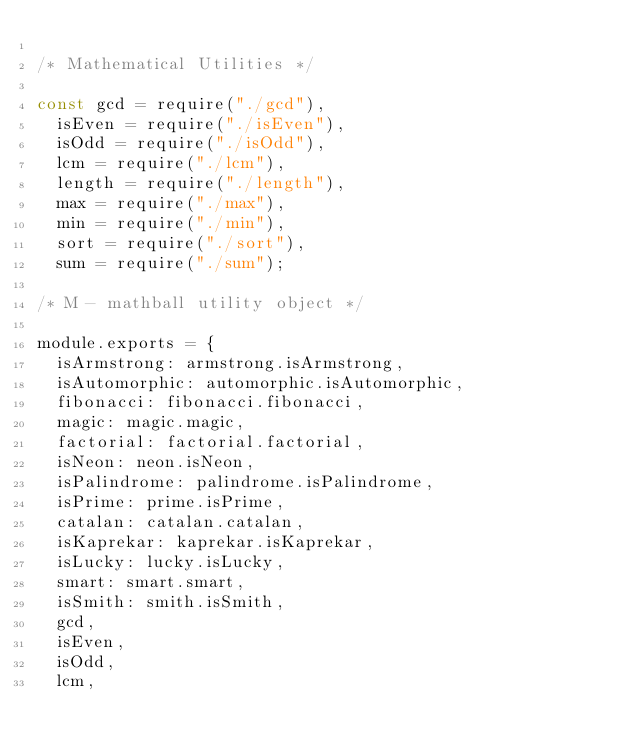Convert code to text. <code><loc_0><loc_0><loc_500><loc_500><_JavaScript_>
/* Mathematical Utilities */

const gcd = require("./gcd"),
	isEven = require("./isEven"),
	isOdd = require("./isOdd"),
	lcm = require("./lcm"),
	length = require("./length"),
	max = require("./max"),
	min = require("./min"),
	sort = require("./sort"),
	sum = require("./sum");

/* M - mathball utility object */

module.exports = {
	isArmstrong: armstrong.isArmstrong,
	isAutomorphic: automorphic.isAutomorphic,
	fibonacci: fibonacci.fibonacci,
	magic: magic.magic,
	factorial: factorial.factorial,
	isNeon: neon.isNeon,
	isPalindrome: palindrome.isPalindrome,
	isPrime: prime.isPrime,
	catalan: catalan.catalan,
	isKaprekar: kaprekar.isKaprekar,
	isLucky: lucky.isLucky,
	smart: smart.smart,
	isSmith: smith.isSmith,
	gcd,
	isEven,
	isOdd,
	lcm,</code> 